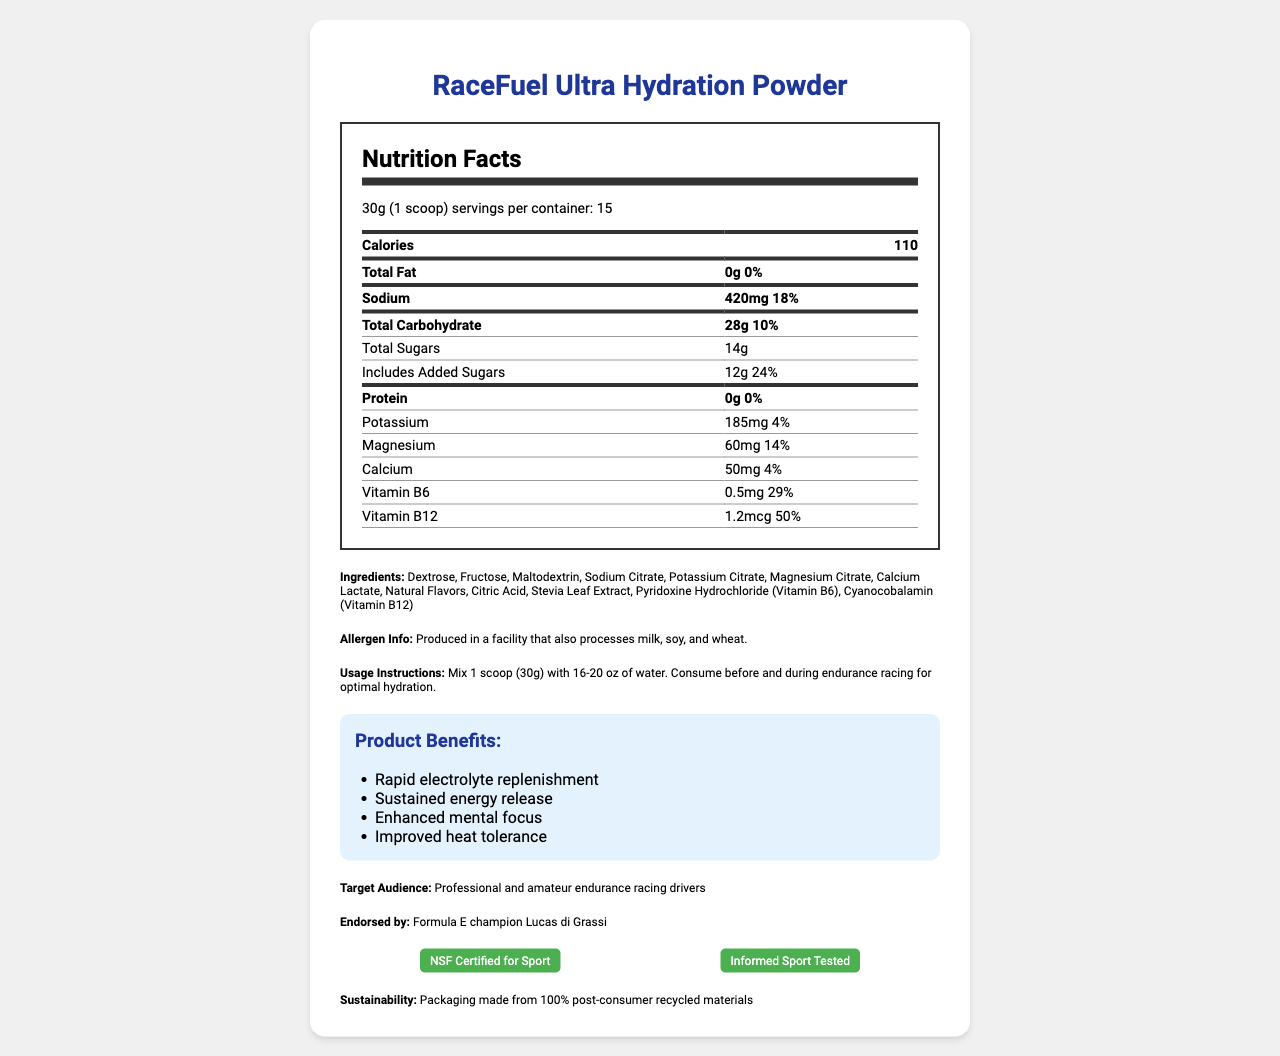what is the serving size of RaceFuel Ultra Hydration Powder? The serving size is stated under the "Nutrition Facts" section.
Answer: 30g (1 scoop) how many servings are there per container? The number of servings per container is mentioned as 15 in the document.
Answer: 15 what is the primary purpose of this product? The document states that the product is formulated for endurance racing drivers for optimal hydration.
Answer: Hydration for endurance racing drivers how much sodium is in a serving of this product? In the nutrition facts section, the sodium content per serving is listed as 420mg.
Answer: 420mg list three ingredients in the RaceFuel Ultra Hydration Powder. Three ingredients mentioned in the ingredients section are Dextrose, Fructose, and Maltodextrin.
Answer: Dextrose, Fructose, Maltodextrin what certifications does this product have? A. USDA Organic B. Fair Trade Certified C. NSF Certified for Sport D. Non-GMO Project Verified The document lists "NSF Certified for Sport" as one of the certifications.
Answer: C. NSF Certified for Sport what is the amount of potassium per serving? A. 150mg B. 175mg C. 185mg D. 200mg The nutrition label states that the potassium content per serving is 185mg.
Answer: C. 185mg is this product suitable for people with soy allergies? The allergen info states that it is produced in a facility that processes soy, making it unsuitable for soy-allergic people.
Answer: No describe the main benefits of using this product. The benefits section lists rapid electrolyte replenishment, sustained energy release, enhanced mental focus, and improved heat tolerance as the main benefits.
Answer: Rapid electrolyte replenishment, Sustained energy release, Enhanced mental focus, Improved heat tolerance who endorses this hydration powder? The document mentions that Formula E champion Lucas di Grassi endorses the product.
Answer: Formula E champion Lucas di Grassi what are the daily values of protein and fat in this product? Both the total fat and protein sections under the nutrition label state that they contribute 0% to daily value.
Answer: 0% how much magnesium does each serving of RaceFuel Ultra Hydration Powder contain? The amount of magnesium per serving is stated as 60mg in the nutrition label.
Answer: 60mg what instruction is given for usage of the product? These instructions are given under the usage instructions section.
Answer: Mix 1 scoop (30g) with 16-20 oz of water. Consume before and during endurance racing for optimal hydration. is this product packaged using recycled materials? The document states that the packaging is made from 100% post-consumer recycled materials.
Answer: Yes how much vitamin B12 does one serving provide relative to the daily value? A. 25% B. 50% C. 75% D. 100% The daily value of Vitamin B12 per serving is listed as 50% in the nutrition facts section.
Answer: B. 50% what is the total amount of sugars in one serving? The nutrition facts section shows that each serving contains 14g of total sugars.
Answer: 14g can the product be determined if it's safe for gluten-sensitive individuals? The document states it is produced in a facility processing wheat, but does not specify regarding the gluten-free status.
Answer: Cannot be determined summarize the entire document. The document includes comprehensive details related to the product's nutritional content, benefits, certifications, and endorsements, promoting it as an effective hydration solution for endurance race drivers.
Answer: The document provides nutritional information, benefits, ingredients, usage instructions, certifications, and endorsements for RaceFuel Ultra Hydration Powder, a hydration product designed for endurance racing drivers. It highlights its electrolyte replenishment, energy release, mental focus enhancement, and heat tolerance improvement benefits, and mentions the use of sustainable packaging. 